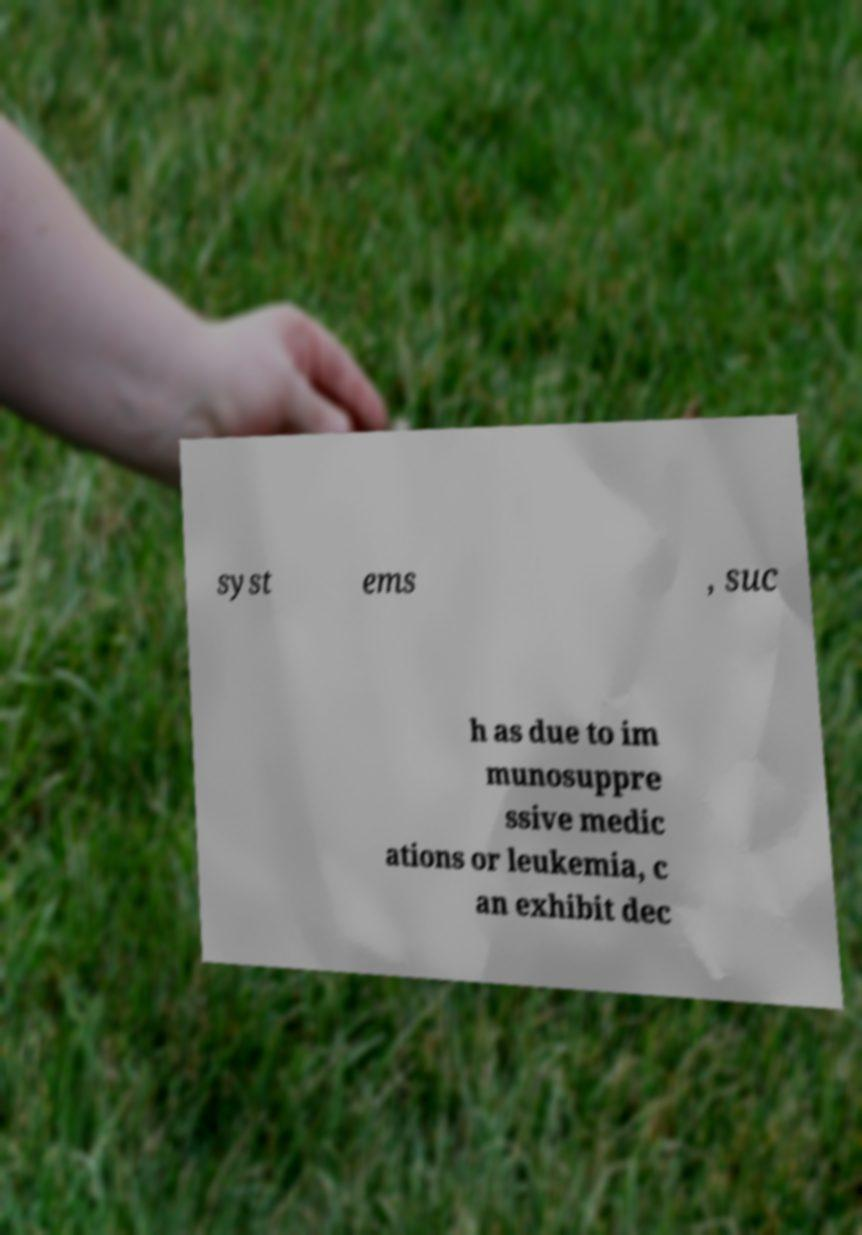Can you read and provide the text displayed in the image?This photo seems to have some interesting text. Can you extract and type it out for me? syst ems , suc h as due to im munosuppre ssive medic ations or leukemia, c an exhibit dec 